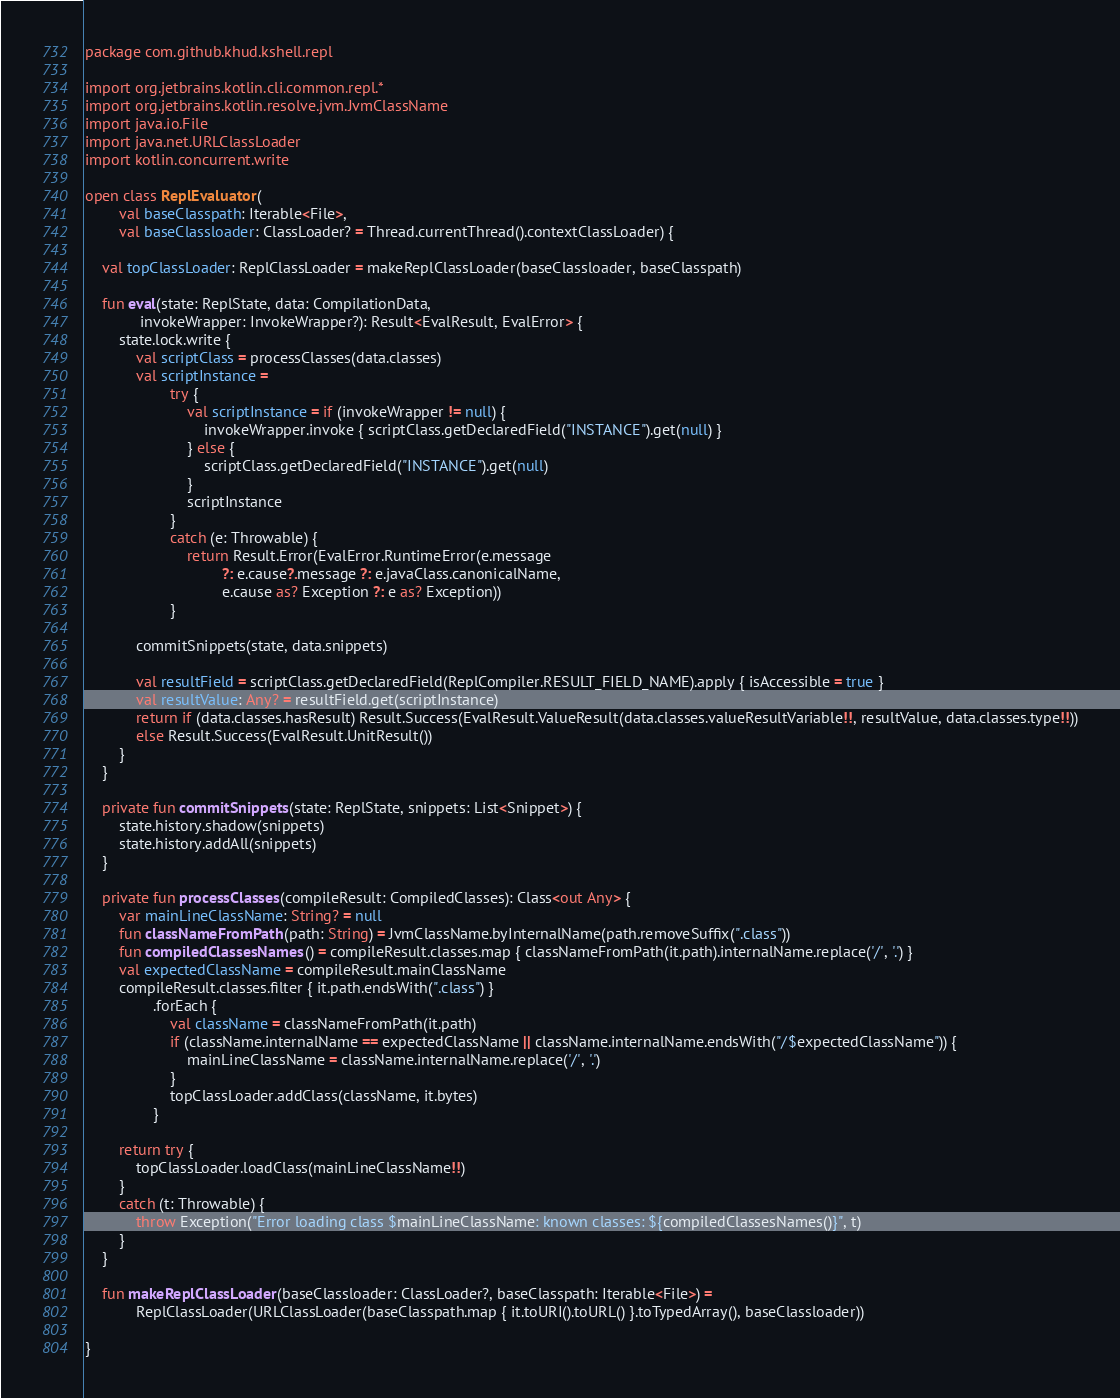Convert code to text. <code><loc_0><loc_0><loc_500><loc_500><_Kotlin_>package com.github.khud.kshell.repl

import org.jetbrains.kotlin.cli.common.repl.*
import org.jetbrains.kotlin.resolve.jvm.JvmClassName
import java.io.File
import java.net.URLClassLoader
import kotlin.concurrent.write

open class ReplEvaluator(
        val baseClasspath: Iterable<File>,
        val baseClassloader: ClassLoader? = Thread.currentThread().contextClassLoader) {

    val topClassLoader: ReplClassLoader = makeReplClassLoader(baseClassloader, baseClasspath)

    fun eval(state: ReplState, data: CompilationData,
             invokeWrapper: InvokeWrapper?): Result<EvalResult, EvalError> {
        state.lock.write {
            val scriptClass = processClasses(data.classes)
            val scriptInstance =
                    try {
                        val scriptInstance = if (invokeWrapper != null) {
                            invokeWrapper.invoke { scriptClass.getDeclaredField("INSTANCE").get(null) }
                        } else {
                            scriptClass.getDeclaredField("INSTANCE").get(null)
                        }
                        scriptInstance
                    }
                    catch (e: Throwable) {
                        return Result.Error(EvalError.RuntimeError(e.message
                                ?: e.cause?.message ?: e.javaClass.canonicalName,
                                e.cause as? Exception ?: e as? Exception))
                    }

            commitSnippets(state, data.snippets)

            val resultField = scriptClass.getDeclaredField(ReplCompiler.RESULT_FIELD_NAME).apply { isAccessible = true }
            val resultValue: Any? = resultField.get(scriptInstance)
            return if (data.classes.hasResult) Result.Success(EvalResult.ValueResult(data.classes.valueResultVariable!!, resultValue, data.classes.type!!))
            else Result.Success(EvalResult.UnitResult())
        }
    }

    private fun commitSnippets(state: ReplState, snippets: List<Snippet>) {
        state.history.shadow(snippets)
        state.history.addAll(snippets)
    }

    private fun processClasses(compileResult: CompiledClasses): Class<out Any> {
        var mainLineClassName: String? = null
        fun classNameFromPath(path: String) = JvmClassName.byInternalName(path.removeSuffix(".class"))
        fun compiledClassesNames() = compileResult.classes.map { classNameFromPath(it.path).internalName.replace('/', '.') }
        val expectedClassName = compileResult.mainClassName
        compileResult.classes.filter { it.path.endsWith(".class") }
                .forEach {
                    val className = classNameFromPath(it.path)
                    if (className.internalName == expectedClassName || className.internalName.endsWith("/$expectedClassName")) {
                        mainLineClassName = className.internalName.replace('/', '.')
                    }
                    topClassLoader.addClass(className, it.bytes)
                }

        return try {
            topClassLoader.loadClass(mainLineClassName!!)
        }
        catch (t: Throwable) {
            throw Exception("Error loading class $mainLineClassName: known classes: ${compiledClassesNames()}", t)
        }
    }

    fun makeReplClassLoader(baseClassloader: ClassLoader?, baseClasspath: Iterable<File>) =
            ReplClassLoader(URLClassLoader(baseClasspath.map { it.toURI().toURL() }.toTypedArray(), baseClassloader))

}</code> 